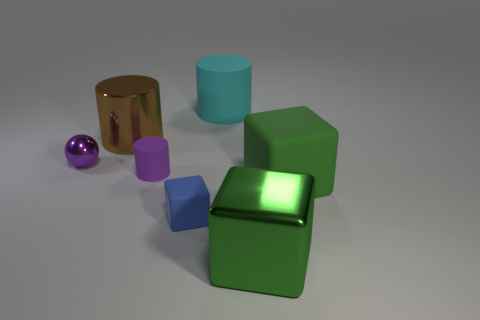Is the shape of the brown object the same as the metallic thing in front of the big green rubber thing? The brown object is a cylinder, while the metallic object is a cube; therefore, their shapes are different. They're positioned in front of what appears to be a larger green cube that has a somewhat rubbery texture. 